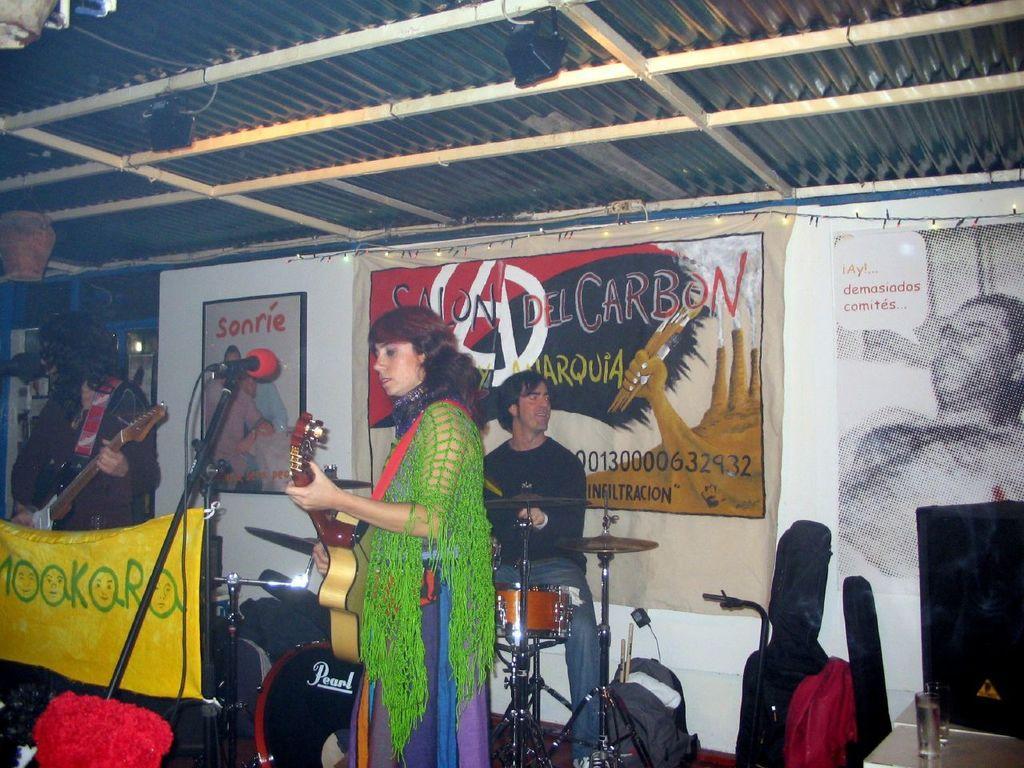Describe this image in one or two sentences. In this image, there are three persons playing the musical instruments. I can see a mike with a mike stand and a cloth. At the bottom of the image, there are bags on the floor. In the bottom right corner of the image, I can see a speaker and a glass on a table. In the background, there are posters and a banner to the wall. At the top of the image, I can see an iron sheet and there are lights and objects to the iron rods. 